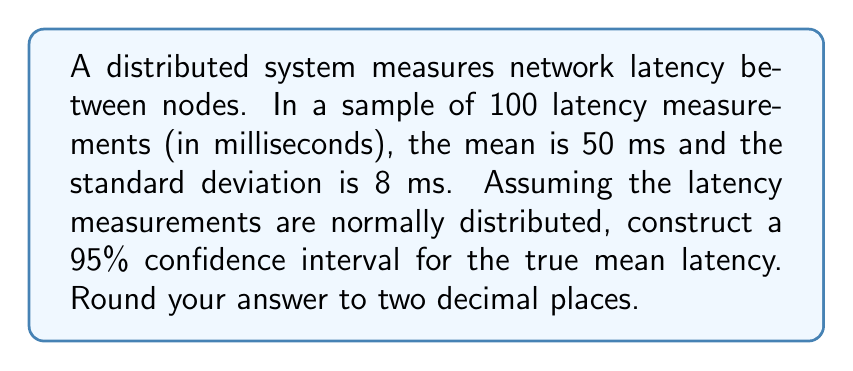Can you answer this question? Для построения доверительного интервала для среднего значения латентности сети, выполним следующие шаги:

1) Формула для доверительного интервала:
   $$\bar{x} \pm t_{\alpha/2, n-1} \cdot \frac{s}{\sqrt{n}}$$
   где:
   $\bar{x}$ - выборочное среднее
   $s$ - выборочное стандартное отклонение
   $n$ - размер выборки
   $t_{\alpha/2, n-1}$ - критическое значение t-распределения

2) Дано:
   $\bar{x} = 50$ мс
   $s = 8$ мс
   $n = 100$
   Уровень доверия = 95% (α = 0.05)

3) Найдем критическое значение t:
   При α = 0.05 и df = n - 1 = 99, $t_{0.025, 99} \approx 1.984$

4) Вычислим стандартную ошибку:
   $$SE = \frac{s}{\sqrt{n}} = \frac{8}{\sqrt{100}} = 0.8$$

5) Рассчитаем границы доверительного интервала:
   Нижняя граница: $50 - (1.984 \cdot 0.8) = 48.41$ мс
   Верхняя граница: $50 + (1.984 \cdot 0.8) = 51.59$ мс

6) Округлим до двух десятичных знаков:
   (48.41, 51.59)
Answer: (48.41, 51.59) мс 